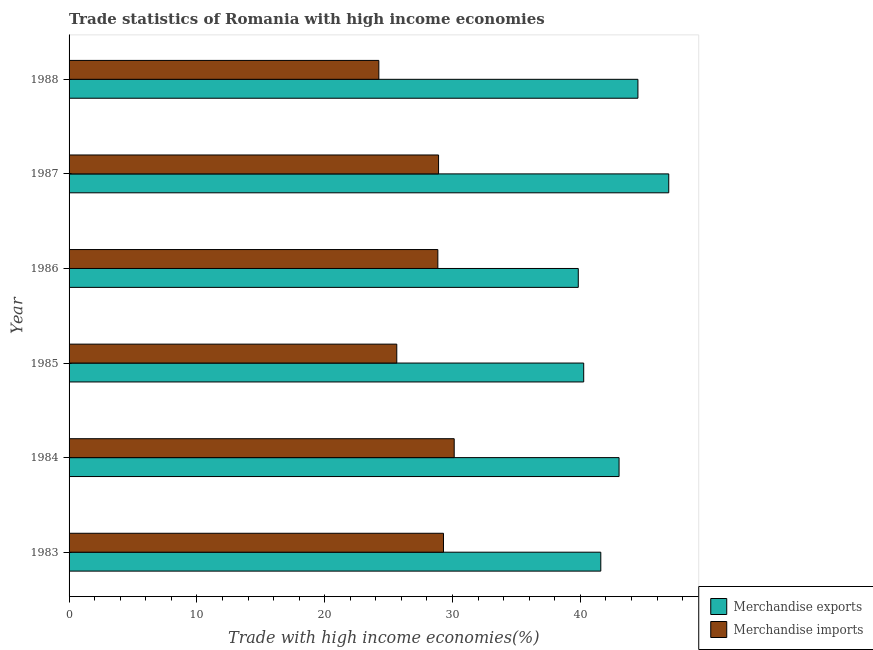How many different coloured bars are there?
Provide a succinct answer. 2. What is the label of the 1st group of bars from the top?
Your answer should be very brief. 1988. What is the merchandise imports in 1988?
Your response must be concise. 24.24. Across all years, what is the maximum merchandise exports?
Your response must be concise. 46.91. Across all years, what is the minimum merchandise exports?
Keep it short and to the point. 39.84. In which year was the merchandise imports maximum?
Your answer should be very brief. 1984. In which year was the merchandise imports minimum?
Ensure brevity in your answer.  1988. What is the total merchandise exports in the graph?
Your response must be concise. 256.14. What is the difference between the merchandise imports in 1986 and that in 1987?
Provide a succinct answer. -0.06. What is the difference between the merchandise imports in 1985 and the merchandise exports in 1987?
Your response must be concise. -21.28. What is the average merchandise imports per year?
Provide a short and direct response. 27.84. In the year 1986, what is the difference between the merchandise exports and merchandise imports?
Provide a succinct answer. 10.99. What is the ratio of the merchandise imports in 1983 to that in 1985?
Offer a terse response. 1.14. Is the merchandise exports in 1985 less than that in 1986?
Offer a terse response. No. Is the difference between the merchandise exports in 1986 and 1988 greater than the difference between the merchandise imports in 1986 and 1988?
Make the answer very short. No. What is the difference between the highest and the second highest merchandise imports?
Your answer should be very brief. 0.84. What is the difference between the highest and the lowest merchandise imports?
Your response must be concise. 5.89. Is the sum of the merchandise exports in 1983 and 1987 greater than the maximum merchandise imports across all years?
Your response must be concise. Yes. What does the 2nd bar from the bottom in 1983 represents?
Your answer should be very brief. Merchandise imports. Does the graph contain any zero values?
Offer a very short reply. No. Does the graph contain grids?
Your response must be concise. No. Where does the legend appear in the graph?
Offer a very short reply. Bottom right. How many legend labels are there?
Keep it short and to the point. 2. What is the title of the graph?
Make the answer very short. Trade statistics of Romania with high income economies. What is the label or title of the X-axis?
Offer a very short reply. Trade with high income economies(%). What is the label or title of the Y-axis?
Give a very brief answer. Year. What is the Trade with high income economies(%) in Merchandise exports in 1983?
Offer a terse response. 41.6. What is the Trade with high income economies(%) of Merchandise imports in 1983?
Offer a very short reply. 29.29. What is the Trade with high income economies(%) in Merchandise exports in 1984?
Keep it short and to the point. 43.03. What is the Trade with high income economies(%) in Merchandise imports in 1984?
Your response must be concise. 30.13. What is the Trade with high income economies(%) of Merchandise exports in 1985?
Your response must be concise. 40.26. What is the Trade with high income economies(%) of Merchandise imports in 1985?
Offer a very short reply. 25.64. What is the Trade with high income economies(%) of Merchandise exports in 1986?
Make the answer very short. 39.84. What is the Trade with high income economies(%) in Merchandise imports in 1986?
Give a very brief answer. 28.85. What is the Trade with high income economies(%) of Merchandise exports in 1987?
Your answer should be compact. 46.91. What is the Trade with high income economies(%) in Merchandise imports in 1987?
Your answer should be compact. 28.91. What is the Trade with high income economies(%) of Merchandise exports in 1988?
Make the answer very short. 44.5. What is the Trade with high income economies(%) in Merchandise imports in 1988?
Keep it short and to the point. 24.24. Across all years, what is the maximum Trade with high income economies(%) in Merchandise exports?
Make the answer very short. 46.91. Across all years, what is the maximum Trade with high income economies(%) in Merchandise imports?
Make the answer very short. 30.13. Across all years, what is the minimum Trade with high income economies(%) in Merchandise exports?
Provide a short and direct response. 39.84. Across all years, what is the minimum Trade with high income economies(%) in Merchandise imports?
Your answer should be compact. 24.24. What is the total Trade with high income economies(%) of Merchandise exports in the graph?
Offer a terse response. 256.14. What is the total Trade with high income economies(%) in Merchandise imports in the graph?
Your answer should be compact. 167.05. What is the difference between the Trade with high income economies(%) in Merchandise exports in 1983 and that in 1984?
Make the answer very short. -1.43. What is the difference between the Trade with high income economies(%) in Merchandise imports in 1983 and that in 1984?
Offer a very short reply. -0.84. What is the difference between the Trade with high income economies(%) in Merchandise exports in 1983 and that in 1985?
Ensure brevity in your answer.  1.34. What is the difference between the Trade with high income economies(%) of Merchandise imports in 1983 and that in 1985?
Ensure brevity in your answer.  3.65. What is the difference between the Trade with high income economies(%) in Merchandise exports in 1983 and that in 1986?
Your answer should be compact. 1.76. What is the difference between the Trade with high income economies(%) of Merchandise imports in 1983 and that in 1986?
Your response must be concise. 0.44. What is the difference between the Trade with high income economies(%) of Merchandise exports in 1983 and that in 1987?
Provide a succinct answer. -5.32. What is the difference between the Trade with high income economies(%) of Merchandise imports in 1983 and that in 1987?
Your answer should be compact. 0.39. What is the difference between the Trade with high income economies(%) of Merchandise exports in 1983 and that in 1988?
Give a very brief answer. -2.91. What is the difference between the Trade with high income economies(%) of Merchandise imports in 1983 and that in 1988?
Keep it short and to the point. 5.06. What is the difference between the Trade with high income economies(%) of Merchandise exports in 1984 and that in 1985?
Your response must be concise. 2.77. What is the difference between the Trade with high income economies(%) in Merchandise imports in 1984 and that in 1985?
Provide a succinct answer. 4.49. What is the difference between the Trade with high income economies(%) in Merchandise exports in 1984 and that in 1986?
Offer a very short reply. 3.19. What is the difference between the Trade with high income economies(%) in Merchandise imports in 1984 and that in 1986?
Make the answer very short. 1.28. What is the difference between the Trade with high income economies(%) in Merchandise exports in 1984 and that in 1987?
Your response must be concise. -3.89. What is the difference between the Trade with high income economies(%) of Merchandise imports in 1984 and that in 1987?
Ensure brevity in your answer.  1.22. What is the difference between the Trade with high income economies(%) of Merchandise exports in 1984 and that in 1988?
Give a very brief answer. -1.48. What is the difference between the Trade with high income economies(%) of Merchandise imports in 1984 and that in 1988?
Keep it short and to the point. 5.89. What is the difference between the Trade with high income economies(%) in Merchandise exports in 1985 and that in 1986?
Give a very brief answer. 0.42. What is the difference between the Trade with high income economies(%) in Merchandise imports in 1985 and that in 1986?
Your response must be concise. -3.21. What is the difference between the Trade with high income economies(%) of Merchandise exports in 1985 and that in 1987?
Your answer should be very brief. -6.65. What is the difference between the Trade with high income economies(%) of Merchandise imports in 1985 and that in 1987?
Make the answer very short. -3.27. What is the difference between the Trade with high income economies(%) of Merchandise exports in 1985 and that in 1988?
Give a very brief answer. -4.24. What is the difference between the Trade with high income economies(%) of Merchandise imports in 1985 and that in 1988?
Your response must be concise. 1.4. What is the difference between the Trade with high income economies(%) of Merchandise exports in 1986 and that in 1987?
Your answer should be very brief. -7.08. What is the difference between the Trade with high income economies(%) in Merchandise imports in 1986 and that in 1987?
Your answer should be compact. -0.06. What is the difference between the Trade with high income economies(%) of Merchandise exports in 1986 and that in 1988?
Keep it short and to the point. -4.67. What is the difference between the Trade with high income economies(%) in Merchandise imports in 1986 and that in 1988?
Your answer should be very brief. 4.61. What is the difference between the Trade with high income economies(%) of Merchandise exports in 1987 and that in 1988?
Your answer should be compact. 2.41. What is the difference between the Trade with high income economies(%) of Merchandise imports in 1987 and that in 1988?
Your response must be concise. 4.67. What is the difference between the Trade with high income economies(%) of Merchandise exports in 1983 and the Trade with high income economies(%) of Merchandise imports in 1984?
Keep it short and to the point. 11.47. What is the difference between the Trade with high income economies(%) of Merchandise exports in 1983 and the Trade with high income economies(%) of Merchandise imports in 1985?
Provide a succinct answer. 15.96. What is the difference between the Trade with high income economies(%) of Merchandise exports in 1983 and the Trade with high income economies(%) of Merchandise imports in 1986?
Your response must be concise. 12.75. What is the difference between the Trade with high income economies(%) in Merchandise exports in 1983 and the Trade with high income economies(%) in Merchandise imports in 1987?
Keep it short and to the point. 12.69. What is the difference between the Trade with high income economies(%) of Merchandise exports in 1983 and the Trade with high income economies(%) of Merchandise imports in 1988?
Ensure brevity in your answer.  17.36. What is the difference between the Trade with high income economies(%) of Merchandise exports in 1984 and the Trade with high income economies(%) of Merchandise imports in 1985?
Give a very brief answer. 17.39. What is the difference between the Trade with high income economies(%) in Merchandise exports in 1984 and the Trade with high income economies(%) in Merchandise imports in 1986?
Your answer should be very brief. 14.18. What is the difference between the Trade with high income economies(%) in Merchandise exports in 1984 and the Trade with high income economies(%) in Merchandise imports in 1987?
Your answer should be very brief. 14.12. What is the difference between the Trade with high income economies(%) of Merchandise exports in 1984 and the Trade with high income economies(%) of Merchandise imports in 1988?
Your answer should be very brief. 18.79. What is the difference between the Trade with high income economies(%) of Merchandise exports in 1985 and the Trade with high income economies(%) of Merchandise imports in 1986?
Provide a short and direct response. 11.41. What is the difference between the Trade with high income economies(%) of Merchandise exports in 1985 and the Trade with high income economies(%) of Merchandise imports in 1987?
Offer a very short reply. 11.36. What is the difference between the Trade with high income economies(%) in Merchandise exports in 1985 and the Trade with high income economies(%) in Merchandise imports in 1988?
Provide a succinct answer. 16.03. What is the difference between the Trade with high income economies(%) of Merchandise exports in 1986 and the Trade with high income economies(%) of Merchandise imports in 1987?
Your answer should be very brief. 10.93. What is the difference between the Trade with high income economies(%) of Merchandise exports in 1986 and the Trade with high income economies(%) of Merchandise imports in 1988?
Provide a succinct answer. 15.6. What is the difference between the Trade with high income economies(%) in Merchandise exports in 1987 and the Trade with high income economies(%) in Merchandise imports in 1988?
Your answer should be very brief. 22.68. What is the average Trade with high income economies(%) in Merchandise exports per year?
Give a very brief answer. 42.69. What is the average Trade with high income economies(%) in Merchandise imports per year?
Provide a succinct answer. 27.84. In the year 1983, what is the difference between the Trade with high income economies(%) in Merchandise exports and Trade with high income economies(%) in Merchandise imports?
Your answer should be very brief. 12.31. In the year 1984, what is the difference between the Trade with high income economies(%) of Merchandise exports and Trade with high income economies(%) of Merchandise imports?
Give a very brief answer. 12.9. In the year 1985, what is the difference between the Trade with high income economies(%) of Merchandise exports and Trade with high income economies(%) of Merchandise imports?
Your response must be concise. 14.62. In the year 1986, what is the difference between the Trade with high income economies(%) of Merchandise exports and Trade with high income economies(%) of Merchandise imports?
Make the answer very short. 10.99. In the year 1987, what is the difference between the Trade with high income economies(%) of Merchandise exports and Trade with high income economies(%) of Merchandise imports?
Your answer should be compact. 18.01. In the year 1988, what is the difference between the Trade with high income economies(%) of Merchandise exports and Trade with high income economies(%) of Merchandise imports?
Make the answer very short. 20.27. What is the ratio of the Trade with high income economies(%) of Merchandise exports in 1983 to that in 1984?
Give a very brief answer. 0.97. What is the ratio of the Trade with high income economies(%) in Merchandise imports in 1983 to that in 1984?
Provide a short and direct response. 0.97. What is the ratio of the Trade with high income economies(%) in Merchandise exports in 1983 to that in 1985?
Offer a terse response. 1.03. What is the ratio of the Trade with high income economies(%) in Merchandise imports in 1983 to that in 1985?
Your answer should be very brief. 1.14. What is the ratio of the Trade with high income economies(%) of Merchandise exports in 1983 to that in 1986?
Provide a short and direct response. 1.04. What is the ratio of the Trade with high income economies(%) in Merchandise imports in 1983 to that in 1986?
Your response must be concise. 1.02. What is the ratio of the Trade with high income economies(%) in Merchandise exports in 1983 to that in 1987?
Offer a terse response. 0.89. What is the ratio of the Trade with high income economies(%) of Merchandise imports in 1983 to that in 1987?
Your answer should be very brief. 1.01. What is the ratio of the Trade with high income economies(%) of Merchandise exports in 1983 to that in 1988?
Offer a very short reply. 0.93. What is the ratio of the Trade with high income economies(%) of Merchandise imports in 1983 to that in 1988?
Give a very brief answer. 1.21. What is the ratio of the Trade with high income economies(%) of Merchandise exports in 1984 to that in 1985?
Provide a succinct answer. 1.07. What is the ratio of the Trade with high income economies(%) in Merchandise imports in 1984 to that in 1985?
Offer a terse response. 1.18. What is the ratio of the Trade with high income economies(%) of Merchandise exports in 1984 to that in 1986?
Your answer should be compact. 1.08. What is the ratio of the Trade with high income economies(%) of Merchandise imports in 1984 to that in 1986?
Provide a short and direct response. 1.04. What is the ratio of the Trade with high income economies(%) in Merchandise exports in 1984 to that in 1987?
Offer a very short reply. 0.92. What is the ratio of the Trade with high income economies(%) in Merchandise imports in 1984 to that in 1987?
Ensure brevity in your answer.  1.04. What is the ratio of the Trade with high income economies(%) of Merchandise exports in 1984 to that in 1988?
Make the answer very short. 0.97. What is the ratio of the Trade with high income economies(%) in Merchandise imports in 1984 to that in 1988?
Give a very brief answer. 1.24. What is the ratio of the Trade with high income economies(%) in Merchandise exports in 1985 to that in 1986?
Keep it short and to the point. 1.01. What is the ratio of the Trade with high income economies(%) in Merchandise imports in 1985 to that in 1986?
Offer a very short reply. 0.89. What is the ratio of the Trade with high income economies(%) in Merchandise exports in 1985 to that in 1987?
Your answer should be very brief. 0.86. What is the ratio of the Trade with high income economies(%) in Merchandise imports in 1985 to that in 1987?
Provide a succinct answer. 0.89. What is the ratio of the Trade with high income economies(%) in Merchandise exports in 1985 to that in 1988?
Provide a succinct answer. 0.9. What is the ratio of the Trade with high income economies(%) of Merchandise imports in 1985 to that in 1988?
Ensure brevity in your answer.  1.06. What is the ratio of the Trade with high income economies(%) in Merchandise exports in 1986 to that in 1987?
Offer a terse response. 0.85. What is the ratio of the Trade with high income economies(%) in Merchandise imports in 1986 to that in 1987?
Ensure brevity in your answer.  1. What is the ratio of the Trade with high income economies(%) in Merchandise exports in 1986 to that in 1988?
Make the answer very short. 0.9. What is the ratio of the Trade with high income economies(%) in Merchandise imports in 1986 to that in 1988?
Ensure brevity in your answer.  1.19. What is the ratio of the Trade with high income economies(%) of Merchandise exports in 1987 to that in 1988?
Make the answer very short. 1.05. What is the ratio of the Trade with high income economies(%) of Merchandise imports in 1987 to that in 1988?
Ensure brevity in your answer.  1.19. What is the difference between the highest and the second highest Trade with high income economies(%) in Merchandise exports?
Ensure brevity in your answer.  2.41. What is the difference between the highest and the second highest Trade with high income economies(%) in Merchandise imports?
Offer a terse response. 0.84. What is the difference between the highest and the lowest Trade with high income economies(%) in Merchandise exports?
Offer a very short reply. 7.08. What is the difference between the highest and the lowest Trade with high income economies(%) of Merchandise imports?
Your answer should be compact. 5.89. 